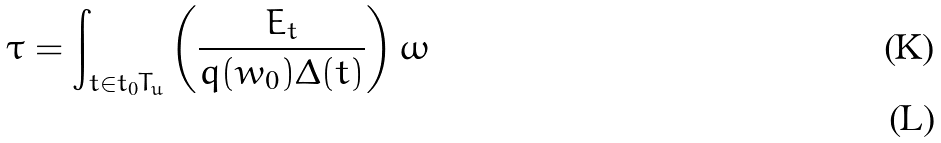Convert formula to latex. <formula><loc_0><loc_0><loc_500><loc_500>\tau = \int _ { t \in t _ { 0 } T _ { u } } \left ( \frac { E _ { t } } { q ( w _ { 0 } ) \Delta ( t ) } \right ) \omega \\</formula> 